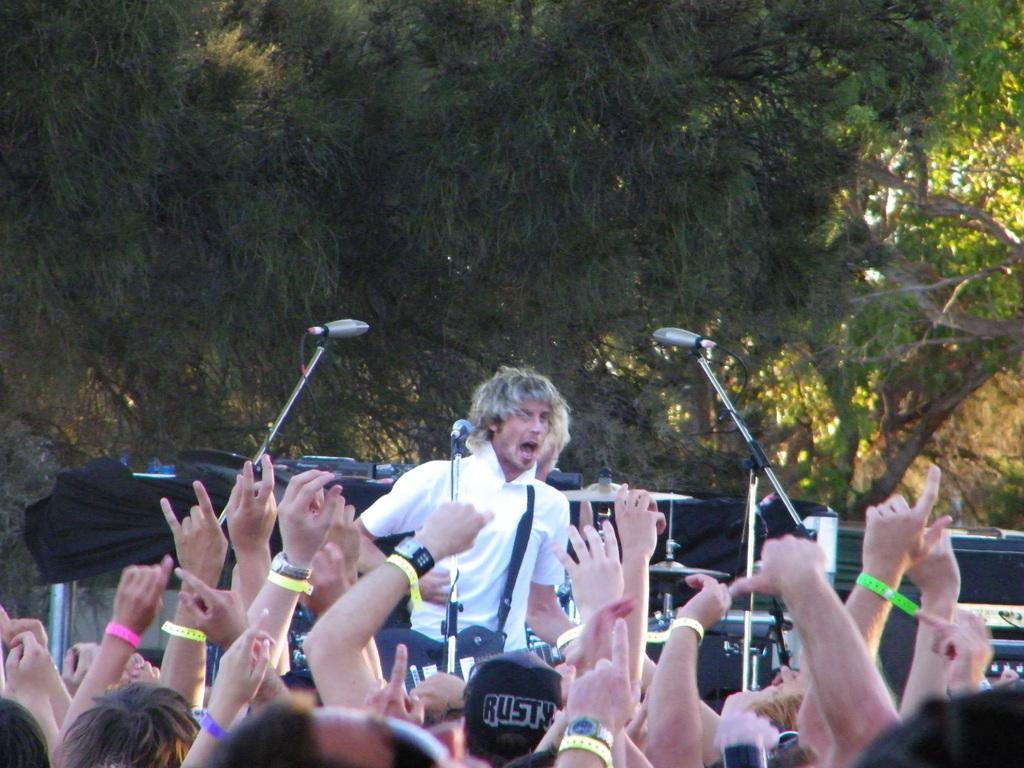Could you give a brief overview of what you see in this image? In this image we can see many people. Some are wearing wrist bands and some are wearing watches. In the back there are mic stands with mics. Also there is a person. In the background there are trees. 